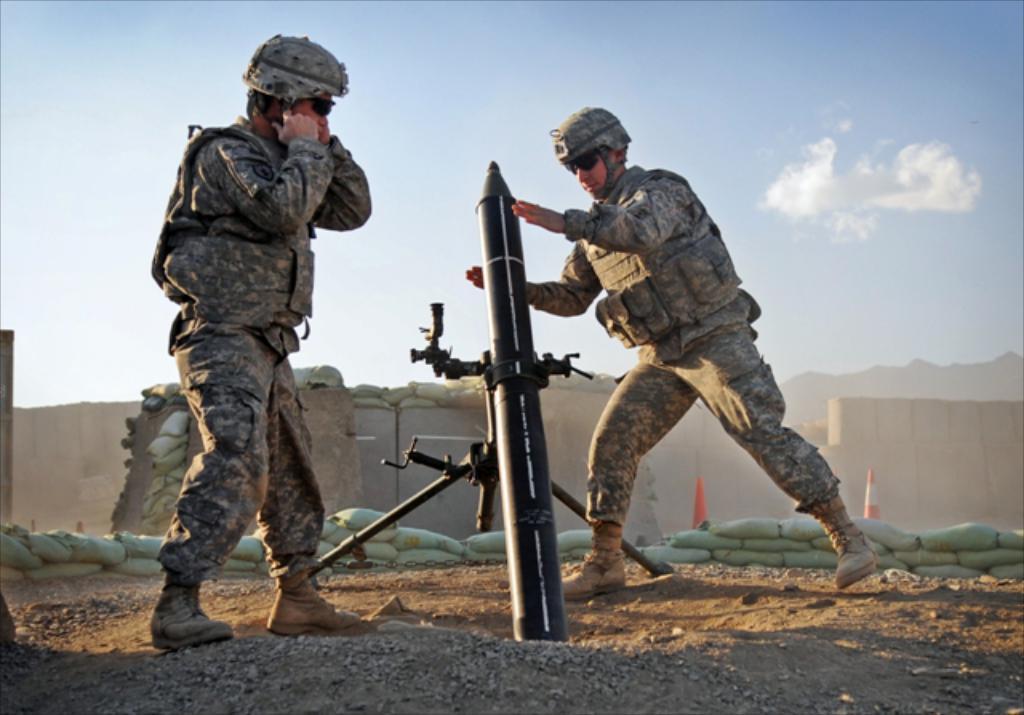Please provide a concise description of this image. In the middle of the image two people are standing and there is a weapon. Behind them there is a wall. At the top of the image there are some clouds and sky. 